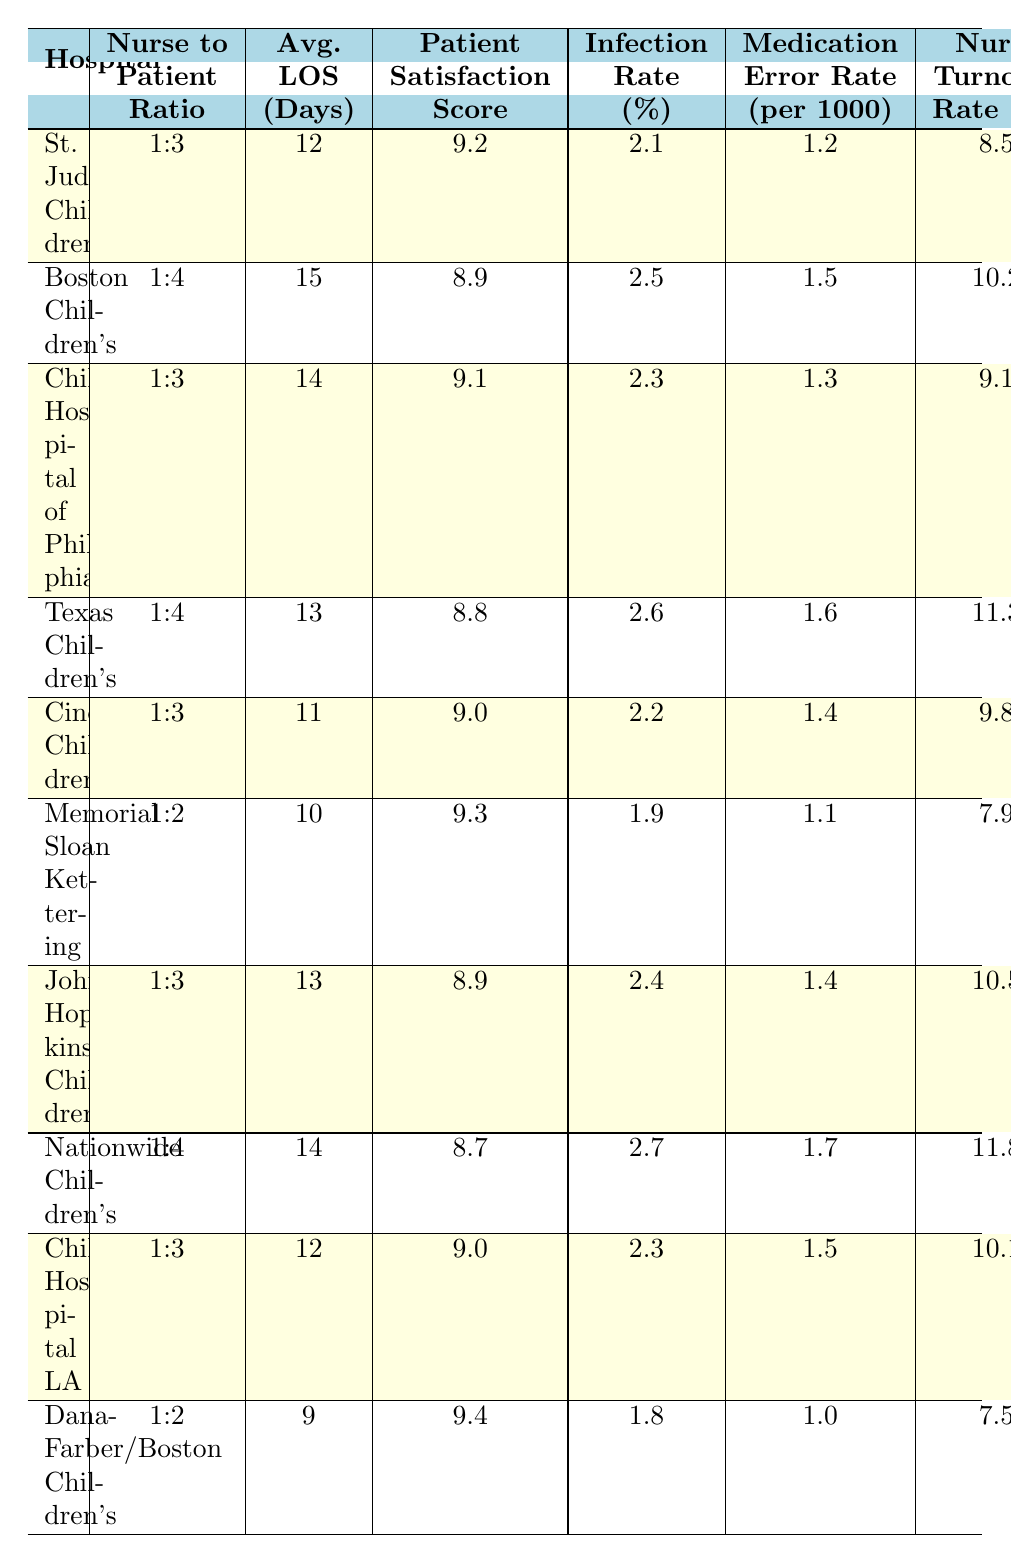What is the Nurse-to-Patient Ratio at Memorial Sloan Kettering Cancer Center? The table lists the Nurse-to-Patient Ratio for each hospital. For Memorial Sloan Kettering Cancer Center, the Nurse-to-Patient Ratio is 1:2.
Answer: 1:2 Which hospital has the highest Patient Satisfaction Score? Looking through the Patient Satisfaction Scores for each hospital, Dana-Farber/Boston Children's has the highest score of 9.4.
Answer: 9.4 What is the average length of stay in days across all hospitals? The average length of stay can be calculated by summing all the Average Length of Stay values (12 + 15 + 14 + 13 + 11 + 10 + 13 + 14 + 12 + 9 =  131) and then dividing by the number of hospitals (10), which gives an average of 13.1 days.
Answer: 13.1 Is the Infection Rate Percentage lower at Dana-Farber/Boston Children's compared to Johns Hopkins Children's Center? The Infection Rate Percentage for Dana-Farber/Boston Children's is 1.8%, and for Johns Hopkins Children's Center, it is 2.4%. Since 1.8% is less than 2.4%, the statement is true.
Answer: Yes What is the relationship between Nurse Turnover Rate and Five Year Survival Rate across these hospitals? To analyze the relationship, we can observe the Nurse Turnover Rate and Five Year Survival Rates for each hospital. Memorial Sloan Kettering has a lower turnover rate (7.9%) and a higher survival rate (83%). In contrast, Texas Children’s has a higher turnover rate (11.3%) and a lower survival rate (79%). Therefore, it seems that lower Nurse Turnover Rate may correlate with a higher Five-Year Survival Rate.
Answer: Lower turnover rates may correlate with higher survival rates What is the average Medication Error Rate per 1000 Patient Days for hospitals with a Nurse-to-Patient Ratio of 1:3? First, we identify the hospitals with a Nurse-to-Patient Ratio of 1:3, which are St. Jude Children's Research Hospital, Children's Hospital of Philadelphia, Cincinnati Children's Hospital, Johns Hopkins Children's Center, and Children's Hospital Los Angeles. The Medication Error Rates for these hospitals are 1.2, 1.3, 1.4, 1.4, and 1.5 respectively. We sum these values (1.2 + 1.3 + 1.4 + 1.4 + 1.5 = 6.8) and divide by the number of hospitals (5), resulting in an average Medication Error Rate of 1.36.
Answer: 1.36 Which hospital has the lowest Nurse Turnover Rate? Reviewing the Nurse Turnover Rate percentages, Dana-Farber/Boston Children's has the lowest rate at 7.5%.
Answer: 7.5% Do hospitals with a Nurse-to-Patient Ratio of 1:2 report higher Patient Satisfaction Scores compared to those with a ratio of 1:4? First, I identify the hospitals with a Nurse-to-Patient Ratio of 1:2 which are Memorial Sloan Kettering (9.3) and Dana-Farber/Boston Children's (9.4). The Patient Satisfaction Scores for hospitals with a 1:4 ratio are Boston Children's Hospital (8.9), Texas Children's Hospital (8.8), Johns Hopkins Children's (8.9), and Nationwide Children's (8.7). The average Patient Satisfaction Score for 1:4 ratio hospitals is 8.83, and the average for 1:2 is 9.35. Therefore, the hospitals with a 1:2 ratio have higher satisfaction scores.
Answer: Yes What is the infection rate at Children's Hospital Los Angeles, and how does it compare to the average infection rate for all hospitals? The Infection Rate Percentage for Children's Hospital Los Angeles is 2.3%. The average infection rate can be calculated by summing all rates (2.1 + 2.5 + 2.3 + 2.6 + 2.2 + 1.9 + 2.4 + 2.7 + 2.3 + 1.8 = 24.8) and dividing by 10, resulting in an average infection rate of 2.48%. Since 2.3% is less than 2.48%, Children's Hospital Los Angeles has a lower infection rate than average.
Answer: Lower than average 